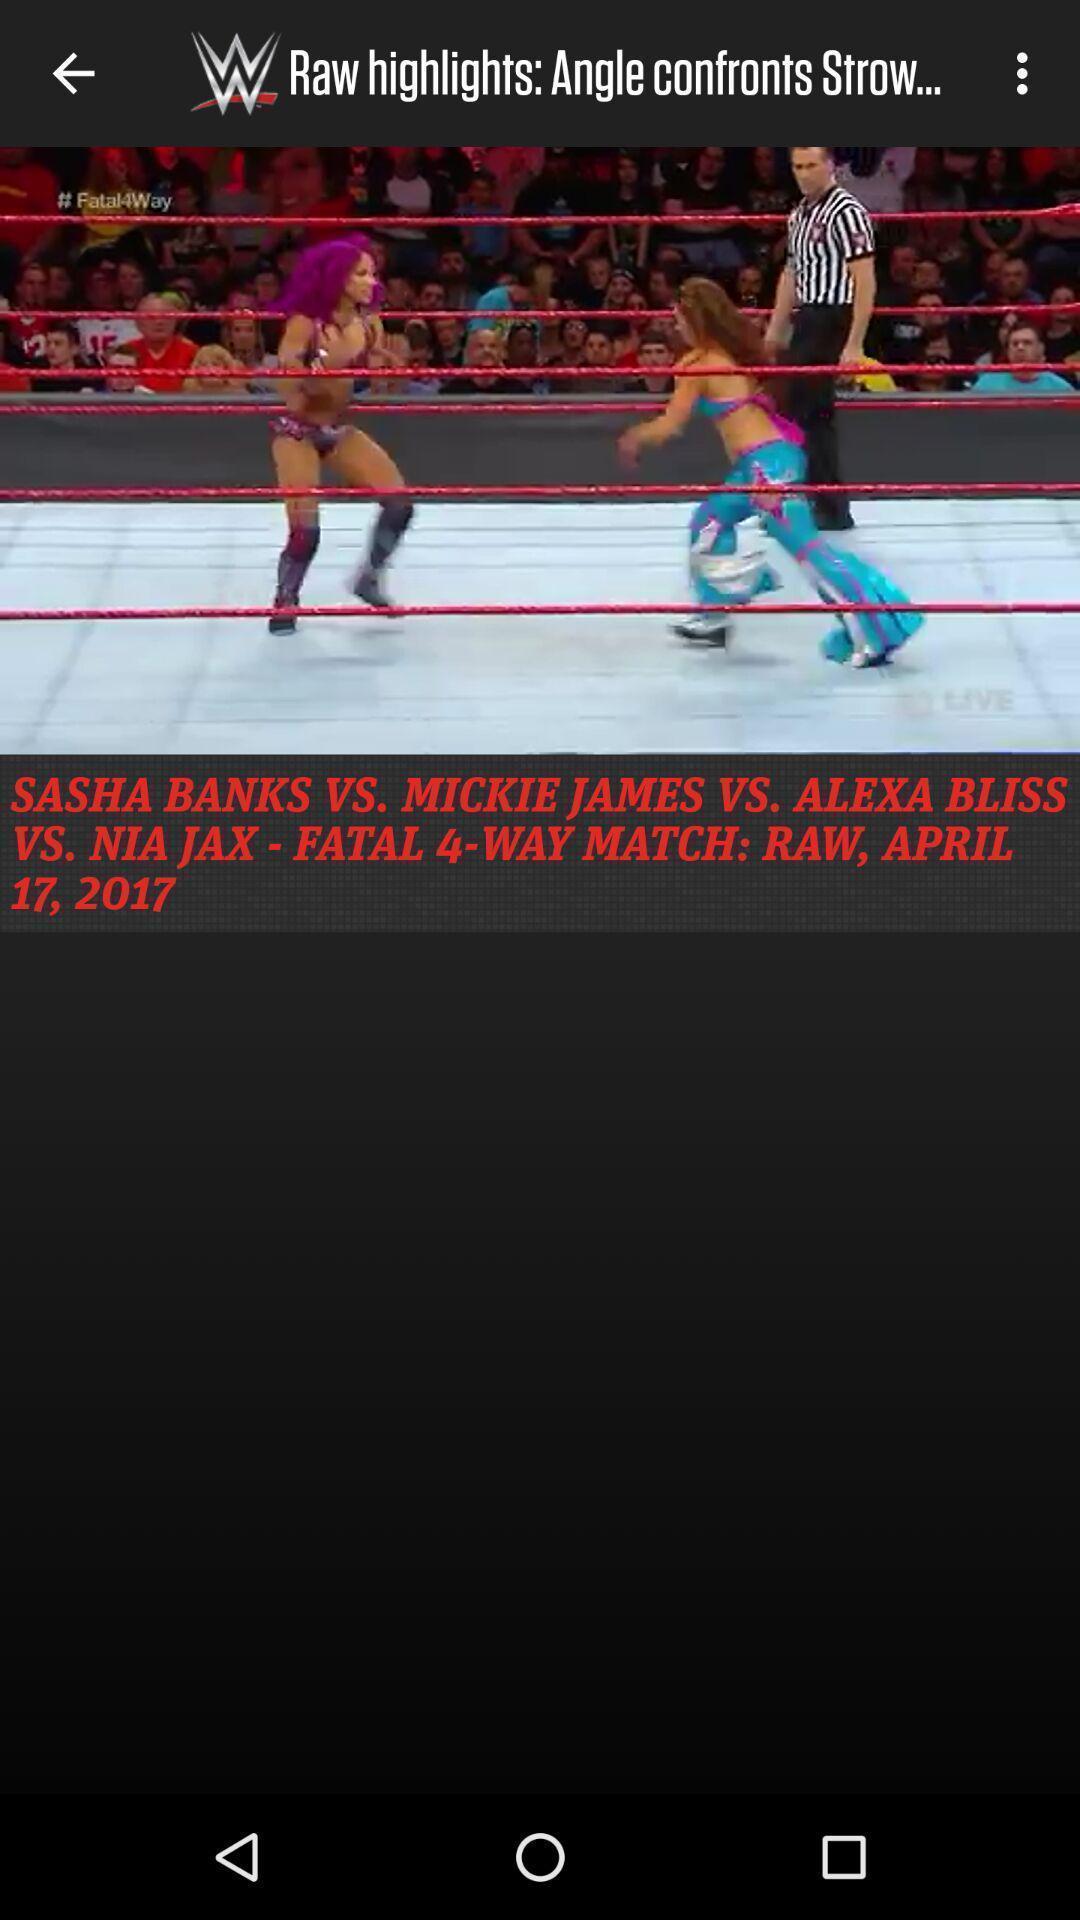Summarize the main components in this picture. Screen displaying the image of a game between 2 players. 